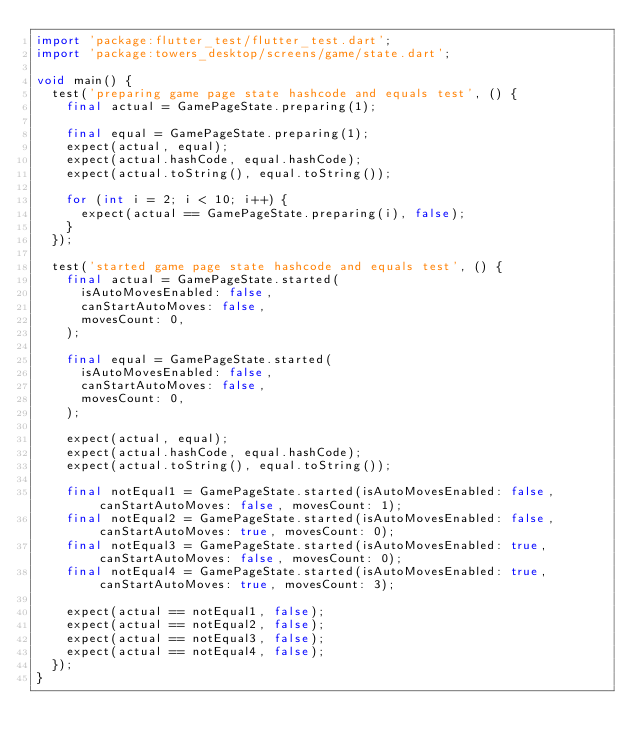<code> <loc_0><loc_0><loc_500><loc_500><_Dart_>import 'package:flutter_test/flutter_test.dart';
import 'package:towers_desktop/screens/game/state.dart';

void main() {
  test('preparing game page state hashcode and equals test', () {
    final actual = GamePageState.preparing(1);

    final equal = GamePageState.preparing(1);
    expect(actual, equal);
    expect(actual.hashCode, equal.hashCode);
    expect(actual.toString(), equal.toString());

    for (int i = 2; i < 10; i++) {
      expect(actual == GamePageState.preparing(i), false);
    }
  });

  test('started game page state hashcode and equals test', () {
    final actual = GamePageState.started(
      isAutoMovesEnabled: false,
      canStartAutoMoves: false,
      movesCount: 0,
    );

    final equal = GamePageState.started(
      isAutoMovesEnabled: false,
      canStartAutoMoves: false,
      movesCount: 0,
    );

    expect(actual, equal);
    expect(actual.hashCode, equal.hashCode);
    expect(actual.toString(), equal.toString());

    final notEqual1 = GamePageState.started(isAutoMovesEnabled: false, canStartAutoMoves: false, movesCount: 1);
    final notEqual2 = GamePageState.started(isAutoMovesEnabled: false, canStartAutoMoves: true, movesCount: 0);
    final notEqual3 = GamePageState.started(isAutoMovesEnabled: true, canStartAutoMoves: false, movesCount: 0);
    final notEqual4 = GamePageState.started(isAutoMovesEnabled: true, canStartAutoMoves: true, movesCount: 3);

    expect(actual == notEqual1, false);
    expect(actual == notEqual2, false);
    expect(actual == notEqual3, false);
    expect(actual == notEqual4, false);
  });
}
</code> 